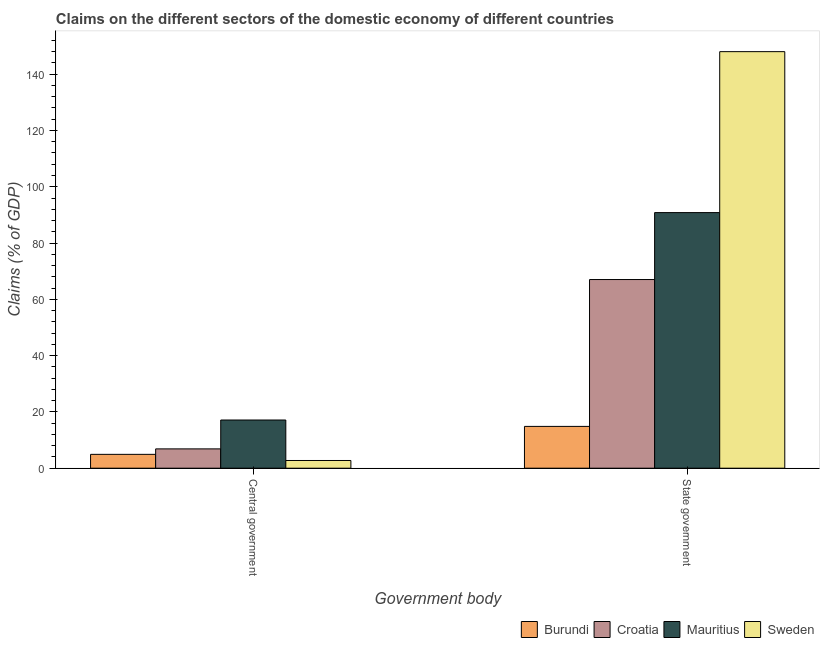How many different coloured bars are there?
Keep it short and to the point. 4. Are the number of bars per tick equal to the number of legend labels?
Keep it short and to the point. Yes. Are the number of bars on each tick of the X-axis equal?
Offer a terse response. Yes. What is the label of the 2nd group of bars from the left?
Provide a succinct answer. State government. What is the claims on state government in Mauritius?
Make the answer very short. 90.82. Across all countries, what is the maximum claims on central government?
Offer a terse response. 17.12. Across all countries, what is the minimum claims on state government?
Offer a terse response. 14.85. In which country was the claims on state government maximum?
Offer a very short reply. Sweden. In which country was the claims on state government minimum?
Make the answer very short. Burundi. What is the total claims on central government in the graph?
Give a very brief answer. 31.64. What is the difference between the claims on state government in Mauritius and that in Croatia?
Offer a terse response. 23.78. What is the difference between the claims on central government in Croatia and the claims on state government in Mauritius?
Make the answer very short. -83.96. What is the average claims on central government per country?
Make the answer very short. 7.91. What is the difference between the claims on central government and claims on state government in Mauritius?
Make the answer very short. -73.7. What is the ratio of the claims on state government in Sweden to that in Burundi?
Keep it short and to the point. 9.97. Is the claims on state government in Burundi less than that in Croatia?
Provide a succinct answer. Yes. What does the 3rd bar from the left in State government represents?
Offer a very short reply. Mauritius. What does the 2nd bar from the right in State government represents?
Provide a succinct answer. Mauritius. Are all the bars in the graph horizontal?
Provide a short and direct response. No. Are the values on the major ticks of Y-axis written in scientific E-notation?
Your answer should be compact. No. Does the graph contain any zero values?
Make the answer very short. No. How many legend labels are there?
Your answer should be compact. 4. What is the title of the graph?
Provide a short and direct response. Claims on the different sectors of the domestic economy of different countries. Does "Marshall Islands" appear as one of the legend labels in the graph?
Offer a terse response. No. What is the label or title of the X-axis?
Provide a succinct answer. Government body. What is the label or title of the Y-axis?
Provide a short and direct response. Claims (% of GDP). What is the Claims (% of GDP) of Burundi in Central government?
Offer a terse response. 4.92. What is the Claims (% of GDP) of Croatia in Central government?
Offer a very short reply. 6.86. What is the Claims (% of GDP) in Mauritius in Central government?
Keep it short and to the point. 17.12. What is the Claims (% of GDP) in Sweden in Central government?
Ensure brevity in your answer.  2.74. What is the Claims (% of GDP) of Burundi in State government?
Make the answer very short. 14.85. What is the Claims (% of GDP) of Croatia in State government?
Ensure brevity in your answer.  67.04. What is the Claims (% of GDP) in Mauritius in State government?
Make the answer very short. 90.82. What is the Claims (% of GDP) in Sweden in State government?
Provide a succinct answer. 148.01. Across all Government body, what is the maximum Claims (% of GDP) of Burundi?
Keep it short and to the point. 14.85. Across all Government body, what is the maximum Claims (% of GDP) of Croatia?
Give a very brief answer. 67.04. Across all Government body, what is the maximum Claims (% of GDP) of Mauritius?
Keep it short and to the point. 90.82. Across all Government body, what is the maximum Claims (% of GDP) in Sweden?
Provide a succinct answer. 148.01. Across all Government body, what is the minimum Claims (% of GDP) in Burundi?
Your response must be concise. 4.92. Across all Government body, what is the minimum Claims (% of GDP) of Croatia?
Provide a succinct answer. 6.86. Across all Government body, what is the minimum Claims (% of GDP) of Mauritius?
Your answer should be very brief. 17.12. Across all Government body, what is the minimum Claims (% of GDP) in Sweden?
Offer a very short reply. 2.74. What is the total Claims (% of GDP) of Burundi in the graph?
Provide a short and direct response. 19.77. What is the total Claims (% of GDP) of Croatia in the graph?
Your response must be concise. 73.9. What is the total Claims (% of GDP) in Mauritius in the graph?
Make the answer very short. 107.94. What is the total Claims (% of GDP) of Sweden in the graph?
Your answer should be compact. 150.75. What is the difference between the Claims (% of GDP) in Burundi in Central government and that in State government?
Ensure brevity in your answer.  -9.93. What is the difference between the Claims (% of GDP) of Croatia in Central government and that in State government?
Your answer should be compact. -60.17. What is the difference between the Claims (% of GDP) of Mauritius in Central government and that in State government?
Keep it short and to the point. -73.7. What is the difference between the Claims (% of GDP) in Sweden in Central government and that in State government?
Ensure brevity in your answer.  -145.27. What is the difference between the Claims (% of GDP) of Burundi in Central government and the Claims (% of GDP) of Croatia in State government?
Provide a succinct answer. -62.12. What is the difference between the Claims (% of GDP) in Burundi in Central government and the Claims (% of GDP) in Mauritius in State government?
Provide a short and direct response. -85.9. What is the difference between the Claims (% of GDP) in Burundi in Central government and the Claims (% of GDP) in Sweden in State government?
Your answer should be compact. -143.09. What is the difference between the Claims (% of GDP) of Croatia in Central government and the Claims (% of GDP) of Mauritius in State government?
Your response must be concise. -83.96. What is the difference between the Claims (% of GDP) of Croatia in Central government and the Claims (% of GDP) of Sweden in State government?
Offer a very short reply. -141.15. What is the difference between the Claims (% of GDP) in Mauritius in Central government and the Claims (% of GDP) in Sweden in State government?
Offer a terse response. -130.89. What is the average Claims (% of GDP) of Burundi per Government body?
Give a very brief answer. 9.88. What is the average Claims (% of GDP) of Croatia per Government body?
Ensure brevity in your answer.  36.95. What is the average Claims (% of GDP) of Mauritius per Government body?
Offer a very short reply. 53.97. What is the average Claims (% of GDP) in Sweden per Government body?
Provide a succinct answer. 75.37. What is the difference between the Claims (% of GDP) of Burundi and Claims (% of GDP) of Croatia in Central government?
Offer a terse response. -1.95. What is the difference between the Claims (% of GDP) in Burundi and Claims (% of GDP) in Mauritius in Central government?
Make the answer very short. -12.2. What is the difference between the Claims (% of GDP) in Burundi and Claims (% of GDP) in Sweden in Central government?
Ensure brevity in your answer.  2.18. What is the difference between the Claims (% of GDP) of Croatia and Claims (% of GDP) of Mauritius in Central government?
Make the answer very short. -10.26. What is the difference between the Claims (% of GDP) in Croatia and Claims (% of GDP) in Sweden in Central government?
Offer a very short reply. 4.13. What is the difference between the Claims (% of GDP) in Mauritius and Claims (% of GDP) in Sweden in Central government?
Offer a very short reply. 14.38. What is the difference between the Claims (% of GDP) of Burundi and Claims (% of GDP) of Croatia in State government?
Give a very brief answer. -52.19. What is the difference between the Claims (% of GDP) in Burundi and Claims (% of GDP) in Mauritius in State government?
Keep it short and to the point. -75.97. What is the difference between the Claims (% of GDP) in Burundi and Claims (% of GDP) in Sweden in State government?
Keep it short and to the point. -133.16. What is the difference between the Claims (% of GDP) of Croatia and Claims (% of GDP) of Mauritius in State government?
Offer a terse response. -23.78. What is the difference between the Claims (% of GDP) of Croatia and Claims (% of GDP) of Sweden in State government?
Your response must be concise. -80.97. What is the difference between the Claims (% of GDP) in Mauritius and Claims (% of GDP) in Sweden in State government?
Make the answer very short. -57.19. What is the ratio of the Claims (% of GDP) in Burundi in Central government to that in State government?
Offer a terse response. 0.33. What is the ratio of the Claims (% of GDP) of Croatia in Central government to that in State government?
Provide a short and direct response. 0.1. What is the ratio of the Claims (% of GDP) in Mauritius in Central government to that in State government?
Give a very brief answer. 0.19. What is the ratio of the Claims (% of GDP) in Sweden in Central government to that in State government?
Ensure brevity in your answer.  0.02. What is the difference between the highest and the second highest Claims (% of GDP) of Burundi?
Make the answer very short. 9.93. What is the difference between the highest and the second highest Claims (% of GDP) of Croatia?
Offer a terse response. 60.17. What is the difference between the highest and the second highest Claims (% of GDP) of Mauritius?
Provide a succinct answer. 73.7. What is the difference between the highest and the second highest Claims (% of GDP) of Sweden?
Your response must be concise. 145.27. What is the difference between the highest and the lowest Claims (% of GDP) in Burundi?
Your answer should be compact. 9.93. What is the difference between the highest and the lowest Claims (% of GDP) in Croatia?
Keep it short and to the point. 60.17. What is the difference between the highest and the lowest Claims (% of GDP) of Mauritius?
Make the answer very short. 73.7. What is the difference between the highest and the lowest Claims (% of GDP) of Sweden?
Make the answer very short. 145.27. 